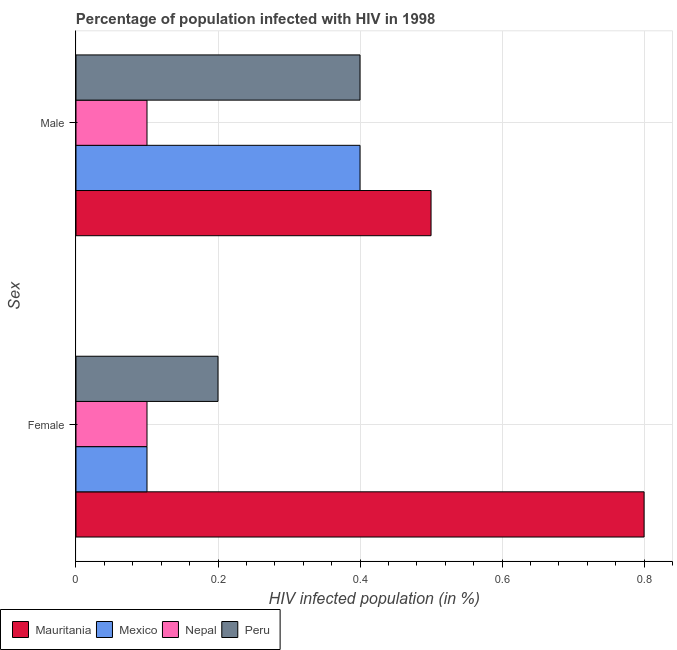How many different coloured bars are there?
Your response must be concise. 4. Are the number of bars per tick equal to the number of legend labels?
Keep it short and to the point. Yes. Are the number of bars on each tick of the Y-axis equal?
Your answer should be compact. Yes. How many bars are there on the 2nd tick from the top?
Your response must be concise. 4. Across all countries, what is the maximum percentage of males who are infected with hiv?
Give a very brief answer. 0.5. Across all countries, what is the minimum percentage of females who are infected with hiv?
Give a very brief answer. 0.1. In which country was the percentage of males who are infected with hiv maximum?
Ensure brevity in your answer.  Mauritania. In which country was the percentage of females who are infected with hiv minimum?
Make the answer very short. Mexico. What is the difference between the percentage of females who are infected with hiv in Peru and that in Mexico?
Your answer should be compact. 0.1. What is the difference between the percentage of males who are infected with hiv in Nepal and the percentage of females who are infected with hiv in Mexico?
Your response must be concise. 0. What is the average percentage of females who are infected with hiv per country?
Your response must be concise. 0.3. What is the difference between the percentage of males who are infected with hiv and percentage of females who are infected with hiv in Mexico?
Provide a succinct answer. 0.3. What is the ratio of the percentage of males who are infected with hiv in Nepal to that in Mexico?
Keep it short and to the point. 0.25. In how many countries, is the percentage of males who are infected with hiv greater than the average percentage of males who are infected with hiv taken over all countries?
Offer a terse response. 3. What does the 3rd bar from the top in Male represents?
Ensure brevity in your answer.  Mexico. How many countries are there in the graph?
Your response must be concise. 4. What is the difference between two consecutive major ticks on the X-axis?
Keep it short and to the point. 0.2. Does the graph contain grids?
Make the answer very short. Yes. What is the title of the graph?
Ensure brevity in your answer.  Percentage of population infected with HIV in 1998. What is the label or title of the X-axis?
Offer a terse response. HIV infected population (in %). What is the label or title of the Y-axis?
Provide a succinct answer. Sex. What is the HIV infected population (in %) in Mexico in Female?
Your answer should be compact. 0.1. What is the HIV infected population (in %) of Peru in Female?
Provide a short and direct response. 0.2. What is the HIV infected population (in %) in Mauritania in Male?
Keep it short and to the point. 0.5. What is the HIV infected population (in %) in Nepal in Male?
Give a very brief answer. 0.1. Across all Sex, what is the maximum HIV infected population (in %) in Mauritania?
Give a very brief answer. 0.8. Across all Sex, what is the maximum HIV infected population (in %) of Mexico?
Offer a terse response. 0.4. Across all Sex, what is the minimum HIV infected population (in %) in Mauritania?
Your answer should be compact. 0.5. Across all Sex, what is the minimum HIV infected population (in %) in Nepal?
Your answer should be very brief. 0.1. Across all Sex, what is the minimum HIV infected population (in %) in Peru?
Offer a terse response. 0.2. What is the total HIV infected population (in %) in Peru in the graph?
Keep it short and to the point. 0.6. What is the difference between the HIV infected population (in %) of Mexico in Female and that in Male?
Keep it short and to the point. -0.3. What is the difference between the HIV infected population (in %) of Nepal in Female and that in Male?
Your answer should be very brief. 0. What is the difference between the HIV infected population (in %) in Mauritania in Female and the HIV infected population (in %) in Mexico in Male?
Provide a succinct answer. 0.4. What is the difference between the HIV infected population (in %) of Mauritania in Female and the HIV infected population (in %) of Nepal in Male?
Offer a very short reply. 0.7. What is the difference between the HIV infected population (in %) in Mexico in Female and the HIV infected population (in %) in Nepal in Male?
Provide a short and direct response. 0. What is the difference between the HIV infected population (in %) of Mexico in Female and the HIV infected population (in %) of Peru in Male?
Your response must be concise. -0.3. What is the average HIV infected population (in %) in Mauritania per Sex?
Provide a short and direct response. 0.65. What is the average HIV infected population (in %) of Mexico per Sex?
Offer a very short reply. 0.25. What is the difference between the HIV infected population (in %) in Mauritania and HIV infected population (in %) in Mexico in Female?
Your answer should be compact. 0.7. What is the difference between the HIV infected population (in %) of Mauritania and HIV infected population (in %) of Nepal in Female?
Keep it short and to the point. 0.7. What is the difference between the HIV infected population (in %) of Mauritania and HIV infected population (in %) of Peru in Female?
Provide a short and direct response. 0.6. What is the difference between the HIV infected population (in %) of Mexico and HIV infected population (in %) of Nepal in Female?
Offer a very short reply. 0. What is the difference between the HIV infected population (in %) in Mexico and HIV infected population (in %) in Peru in Female?
Your answer should be compact. -0.1. What is the difference between the HIV infected population (in %) in Nepal and HIV infected population (in %) in Peru in Female?
Offer a very short reply. -0.1. What is the difference between the HIV infected population (in %) in Mauritania and HIV infected population (in %) in Mexico in Male?
Your answer should be very brief. 0.1. What is the difference between the HIV infected population (in %) of Mauritania and HIV infected population (in %) of Nepal in Male?
Keep it short and to the point. 0.4. What is the difference between the HIV infected population (in %) in Mauritania and HIV infected population (in %) in Peru in Male?
Offer a very short reply. 0.1. What is the difference between the HIV infected population (in %) in Mexico and HIV infected population (in %) in Peru in Male?
Provide a succinct answer. 0. What is the ratio of the HIV infected population (in %) of Mexico in Female to that in Male?
Provide a short and direct response. 0.25. What is the ratio of the HIV infected population (in %) in Nepal in Female to that in Male?
Provide a succinct answer. 1. What is the ratio of the HIV infected population (in %) of Peru in Female to that in Male?
Provide a succinct answer. 0.5. What is the difference between the highest and the second highest HIV infected population (in %) in Mauritania?
Provide a short and direct response. 0.3. What is the difference between the highest and the second highest HIV infected population (in %) in Mexico?
Offer a very short reply. 0.3. What is the difference between the highest and the second highest HIV infected population (in %) of Nepal?
Ensure brevity in your answer.  0. What is the difference between the highest and the lowest HIV infected population (in %) in Mauritania?
Offer a very short reply. 0.3. What is the difference between the highest and the lowest HIV infected population (in %) of Mexico?
Offer a very short reply. 0.3. What is the difference between the highest and the lowest HIV infected population (in %) of Nepal?
Provide a succinct answer. 0. 